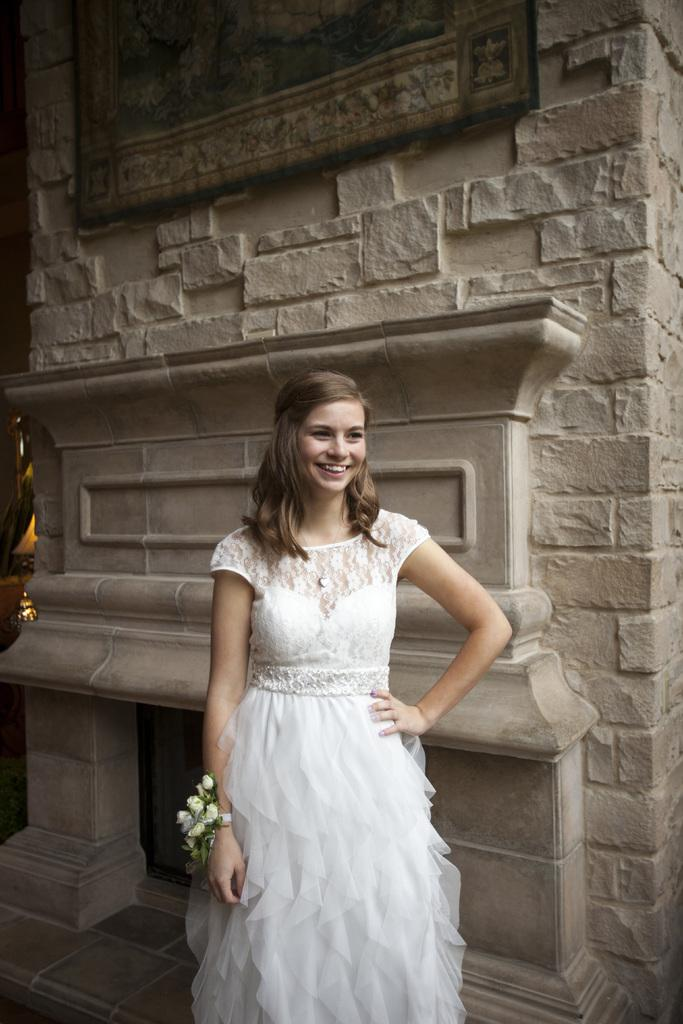Who is the main subject in the image? There is a girl in the image. What is the girl wearing? The girl is wearing a white dress. Are there any accessories visible on the girl? Yes, the girl has a flower bracelet. What is the background of the image? The girl is standing in front of a wall. What is the girl doing in the image? The girl is posing for a photo. What type of holiday is the girl celebrating in the image? There is no indication of a holiday in the image. Can you see an oven in the background of the image? No, there is no oven present in the image. 